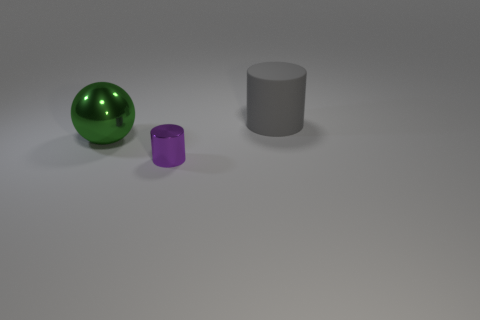Are there any other things that have the same size as the purple cylinder?
Offer a very short reply. No. Is the purple thing made of the same material as the cylinder that is to the right of the small thing?
Give a very brief answer. No. Does the cylinder to the left of the big matte cylinder have the same color as the rubber object?
Offer a very short reply. No. What number of objects are both on the right side of the tiny purple cylinder and on the left side of the big cylinder?
Offer a terse response. 0. What number of other things are there of the same material as the green ball
Make the answer very short. 1. Is the cylinder that is in front of the big cylinder made of the same material as the large gray cylinder?
Provide a short and direct response. No. What is the size of the metal thing to the left of the metallic object to the right of the large thing that is in front of the gray thing?
Make the answer very short. Large. There is a matte thing that is the same size as the ball; what shape is it?
Keep it short and to the point. Cylinder. There is a cylinder that is behind the green sphere; how big is it?
Ensure brevity in your answer.  Large. There is a big object that is behind the big green object; is its color the same as the cylinder that is on the left side of the big gray cylinder?
Ensure brevity in your answer.  No. 